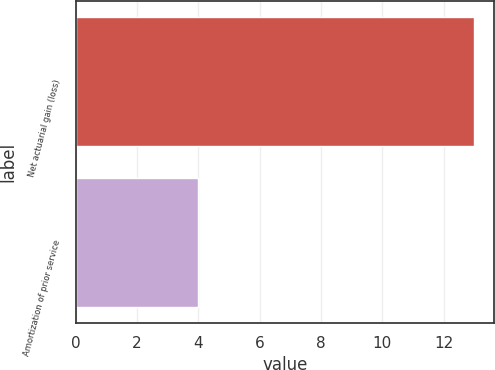<chart> <loc_0><loc_0><loc_500><loc_500><bar_chart><fcel>Net actuarial gain (loss)<fcel>Amortization of prior service<nl><fcel>13<fcel>4<nl></chart> 